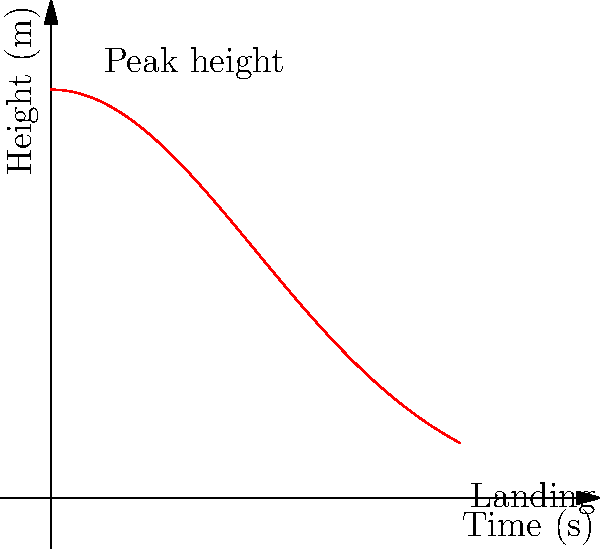Based on the trajectory of a gymnast's center of mass during a floor routine, as shown in the graph, estimate the gymnast's score if the judges heavily favor maximum height and smooth landings. Assume the routine's execution was flawless in all other aspects. To estimate the gymnast's score, we need to analyze the key aspects of the trajectory:

1. Maximum height:
   The peak of the curve is at approximately 4 meters, which is impressive for a floor routine.

2. Smooth landing:
   The curve approaches zero smoothly at the end, indicating a controlled landing.

3. Overall shape:
   The symmetrical, bell-shaped curve suggests good control throughout the movement.

4. Duration:
   The routine lasts about 4 seconds, which is a reasonable time for a complex acrobatic element.

Given these observations:

- The maximum height of 4 meters is excellent, likely earning high difficulty points.
- The smooth landing, as indicated by the gradual descent to zero, would prevent deductions.
- The overall symmetry and control shown in the curve would contribute to high execution scores.

Assuming a perfect 10-point system:
- Difficulty: 9.5/10 (due to impressive height)
- Execution: 9.8/10 (near-perfect, with the smooth landing)

Final score estimate: $(9.5 + 9.8) / 2 = 9.65$

This score reflects the high difficulty and near-perfect execution, with a slight room for improvement in either aspect.
Answer: 9.65 out of 10 